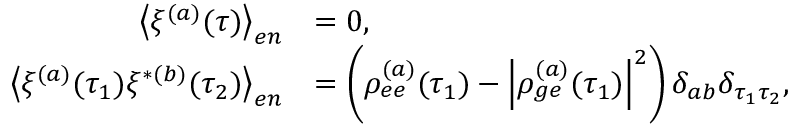<formula> <loc_0><loc_0><loc_500><loc_500>\begin{array} { r l } { \left \langle \xi ^ { ( a ) } ( \tau ) \right \rangle _ { e n } } & { = 0 , } \\ { \left \langle \xi ^ { ( a ) } ( \tau _ { 1 } ) \xi ^ { * ( b ) } ( \tau _ { 2 } ) \right \rangle _ { e n } } & { = \left ( \rho _ { e e } ^ { ( a ) } ( \tau _ { 1 } ) - \left | \rho _ { g e } ^ { ( a ) } ( \tau _ { 1 } ) \right | ^ { 2 } \right ) \delta _ { a b } \delta _ { \tau _ { 1 } \tau _ { 2 } } , } \end{array}</formula> 